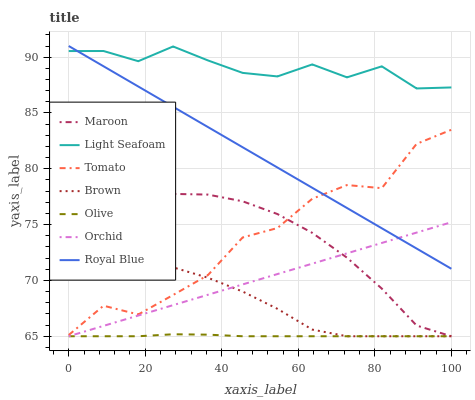Does Olive have the minimum area under the curve?
Answer yes or no. Yes. Does Light Seafoam have the maximum area under the curve?
Answer yes or no. Yes. Does Brown have the minimum area under the curve?
Answer yes or no. No. Does Brown have the maximum area under the curve?
Answer yes or no. No. Is Orchid the smoothest?
Answer yes or no. Yes. Is Tomato the roughest?
Answer yes or no. Yes. Is Brown the smoothest?
Answer yes or no. No. Is Brown the roughest?
Answer yes or no. No. Does Royal Blue have the lowest value?
Answer yes or no. No. Does Brown have the highest value?
Answer yes or no. No. Is Orchid less than Tomato?
Answer yes or no. Yes. Is Tomato greater than Orchid?
Answer yes or no. Yes. Does Orchid intersect Tomato?
Answer yes or no. No. 